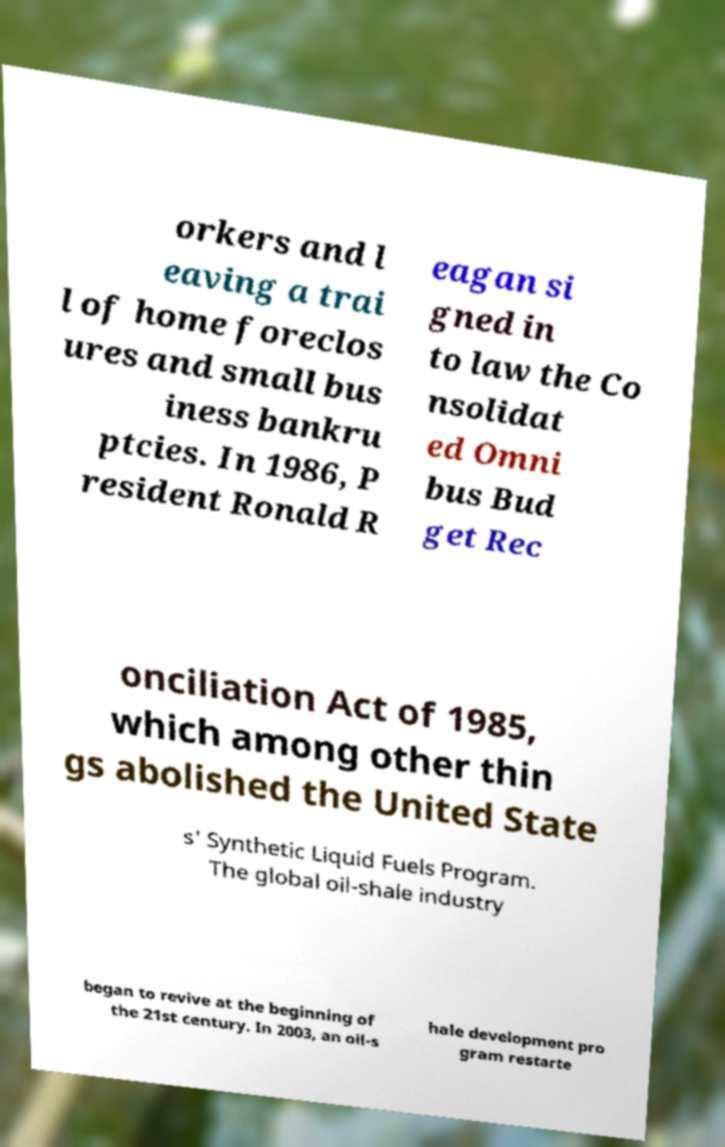Can you read and provide the text displayed in the image?This photo seems to have some interesting text. Can you extract and type it out for me? orkers and l eaving a trai l of home foreclos ures and small bus iness bankru ptcies. In 1986, P resident Ronald R eagan si gned in to law the Co nsolidat ed Omni bus Bud get Rec onciliation Act of 1985, which among other thin gs abolished the United State s' Synthetic Liquid Fuels Program. The global oil-shale industry began to revive at the beginning of the 21st century. In 2003, an oil-s hale development pro gram restarte 